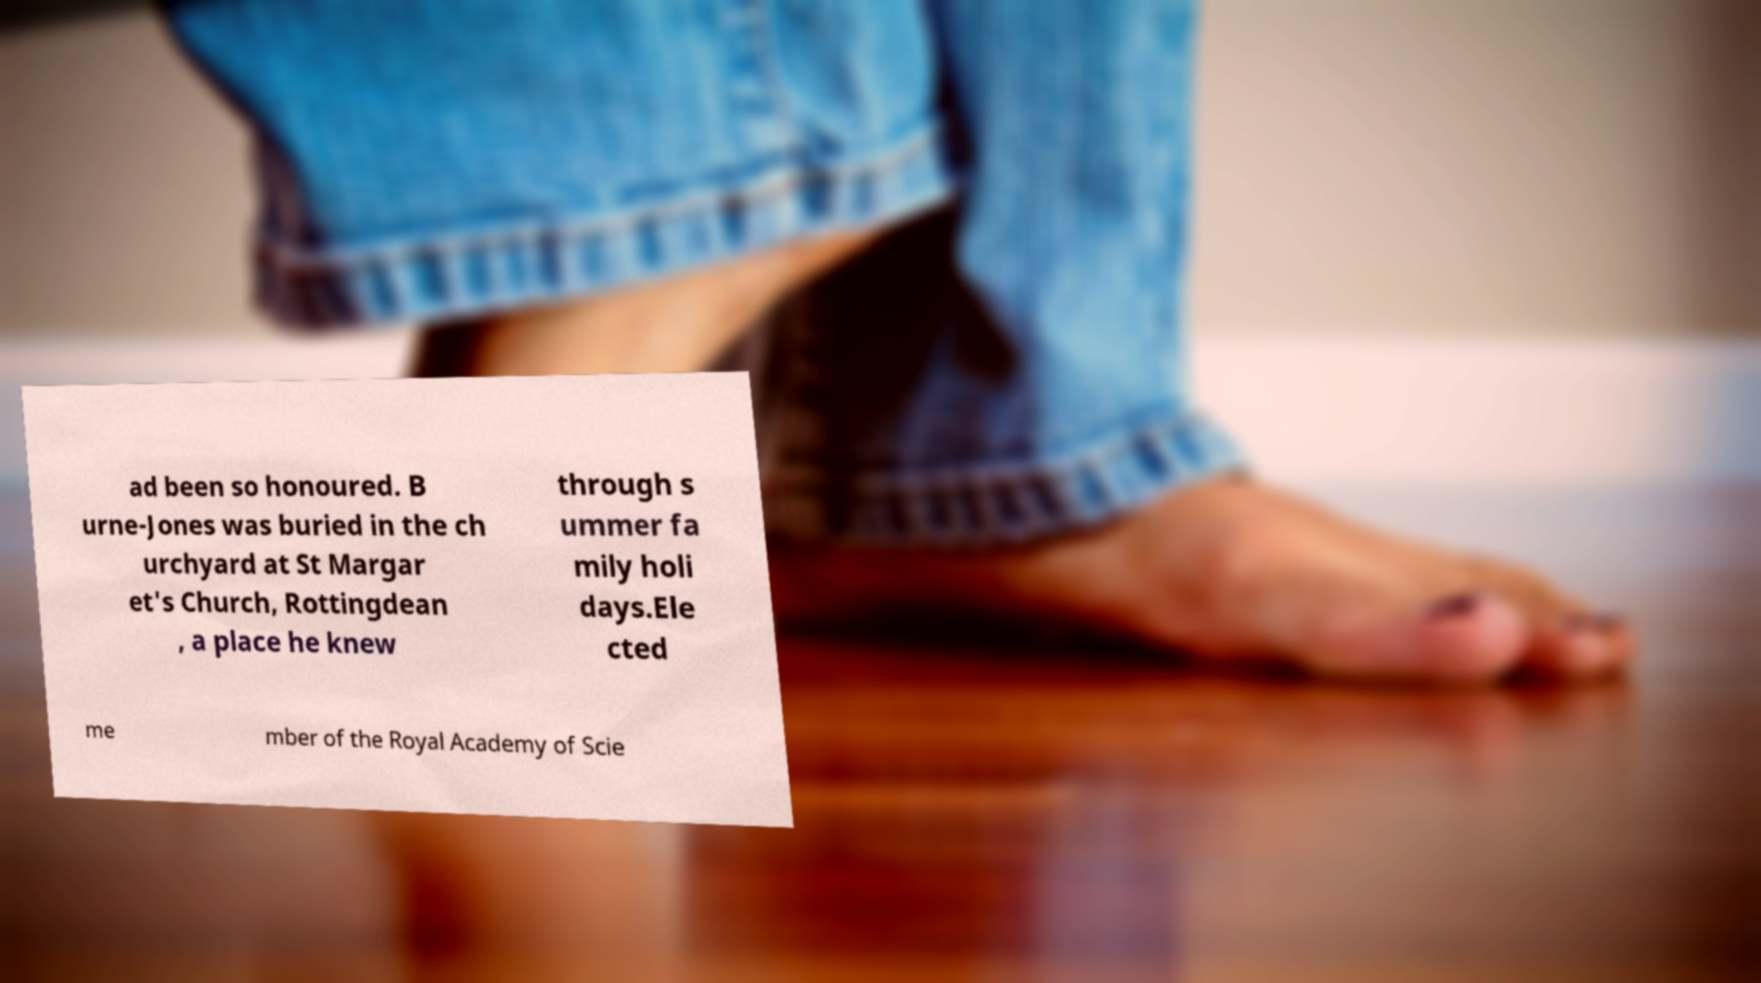There's text embedded in this image that I need extracted. Can you transcribe it verbatim? ad been so honoured. B urne-Jones was buried in the ch urchyard at St Margar et's Church, Rottingdean , a place he knew through s ummer fa mily holi days.Ele cted me mber of the Royal Academy of Scie 